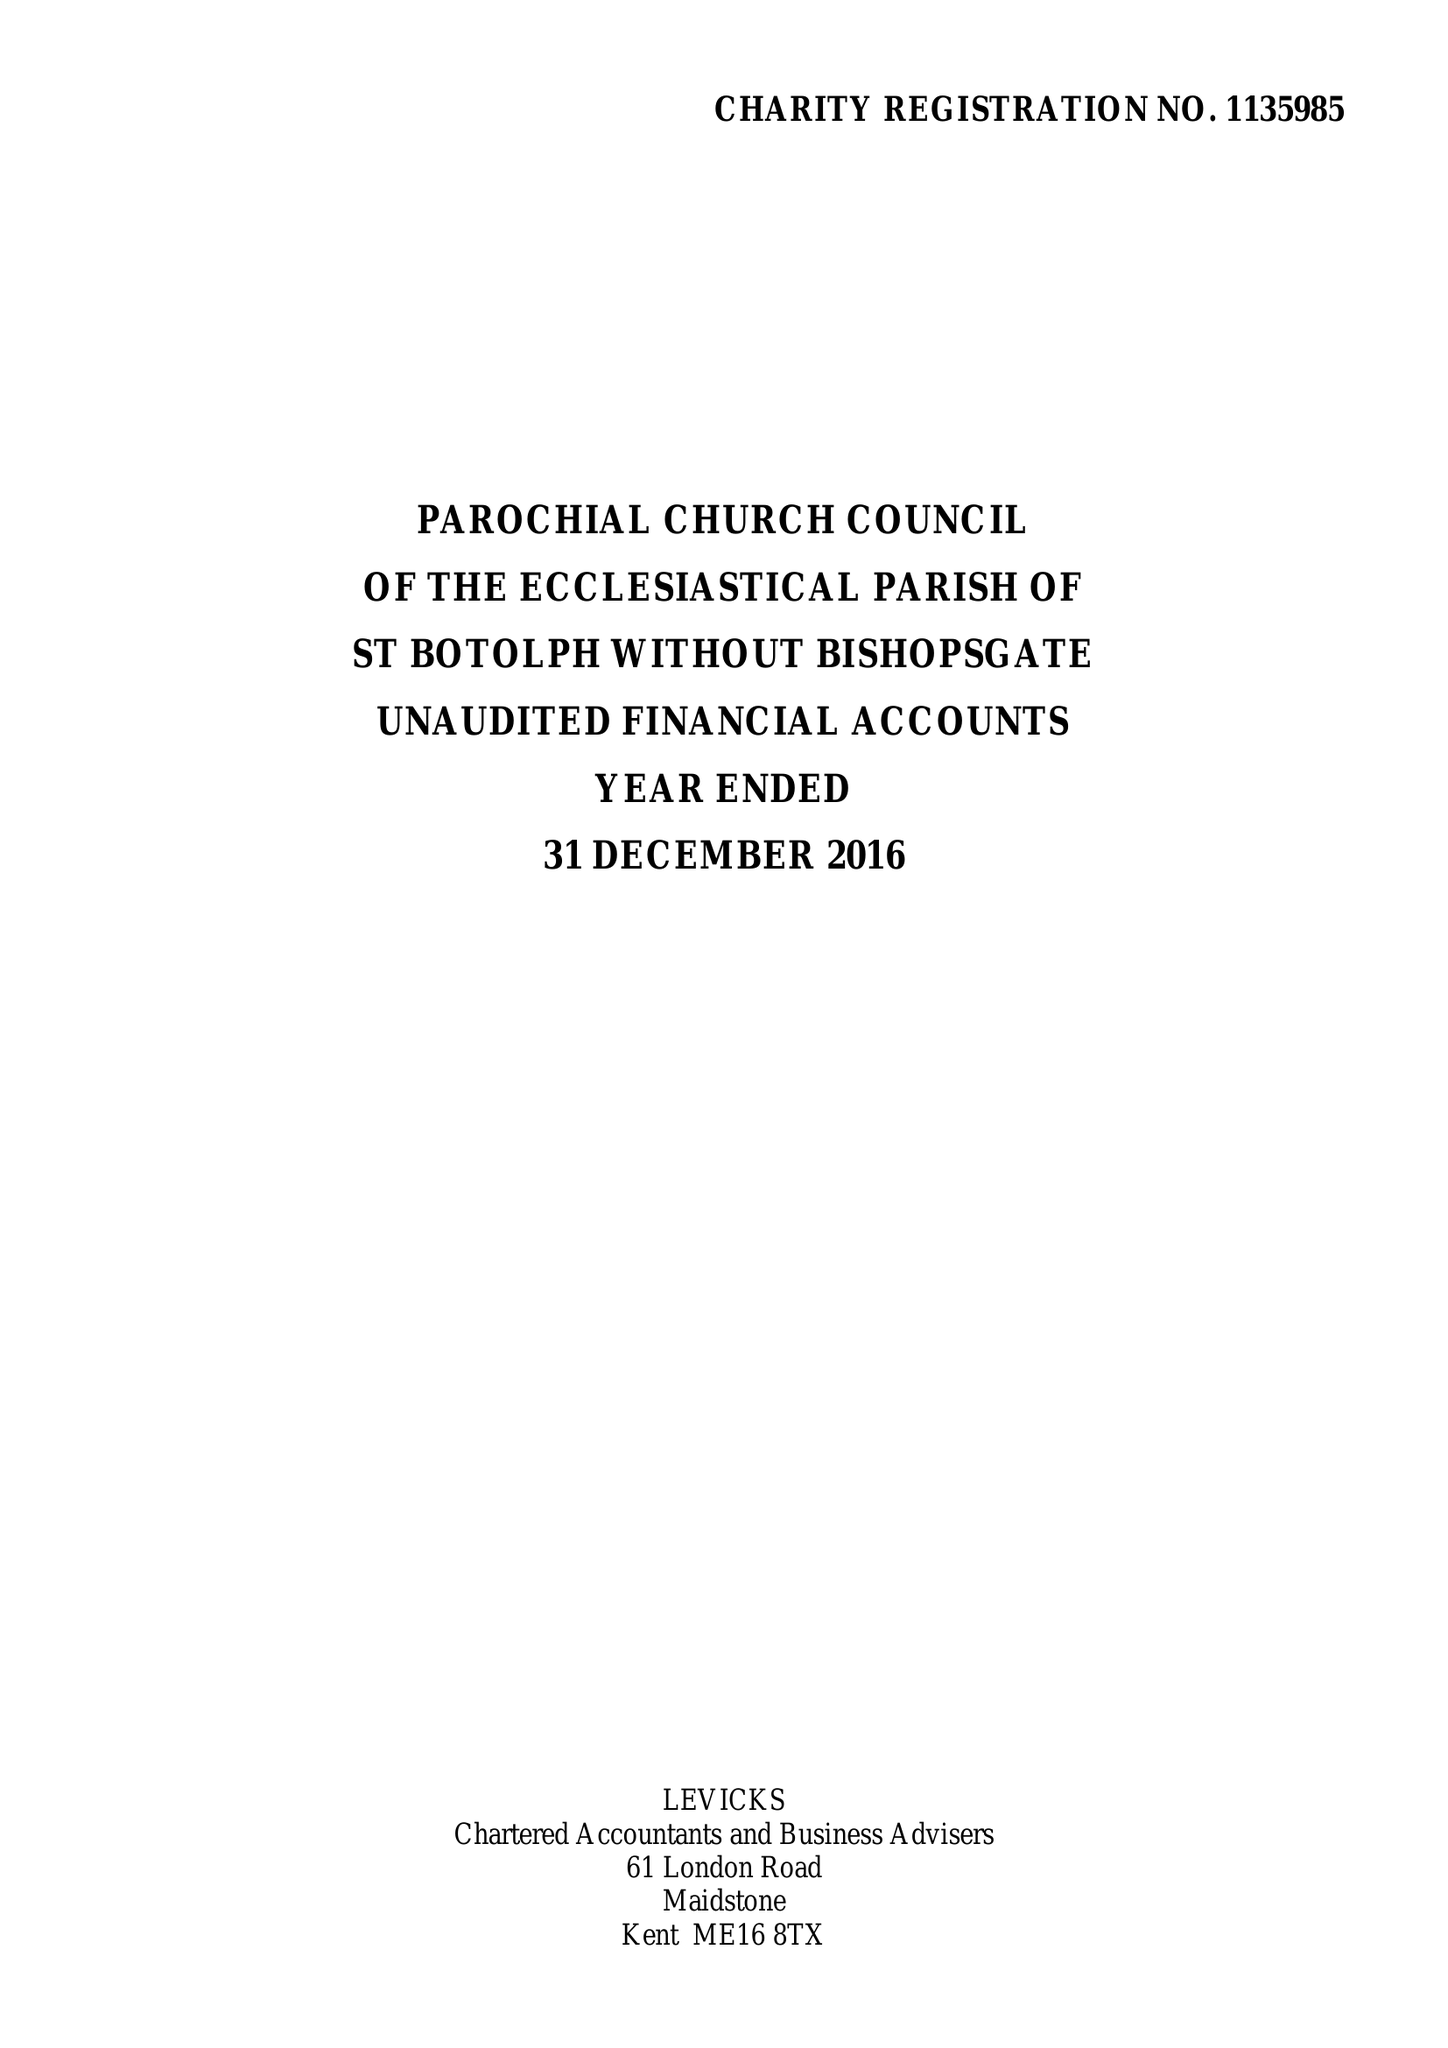What is the value for the address__post_town?
Answer the question using a single word or phrase. LONDON 